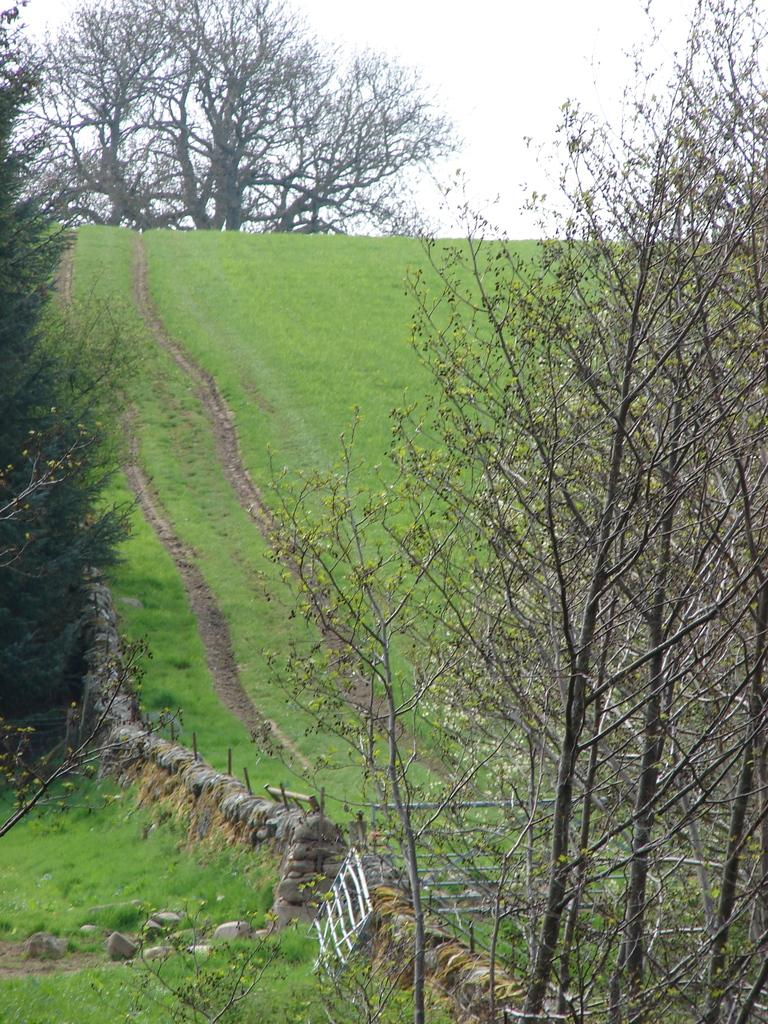What type of vegetation is present in the image? There are trees in the image. What is on the ground in the image? A: There is grass on the ground in the image. What other objects can be seen on the ground? There are stones in the image. What is visible in the background of the image? The sky is visible in the background of the image. What type of structure is present in the image? There is a wall in the image. Which direction is the shoe facing in the image? There is no shoe present in the image. What color is the sky in the north part of the image? The image does not specify a direction or color for the sky; it only mentions that the sky is visible in the background. 